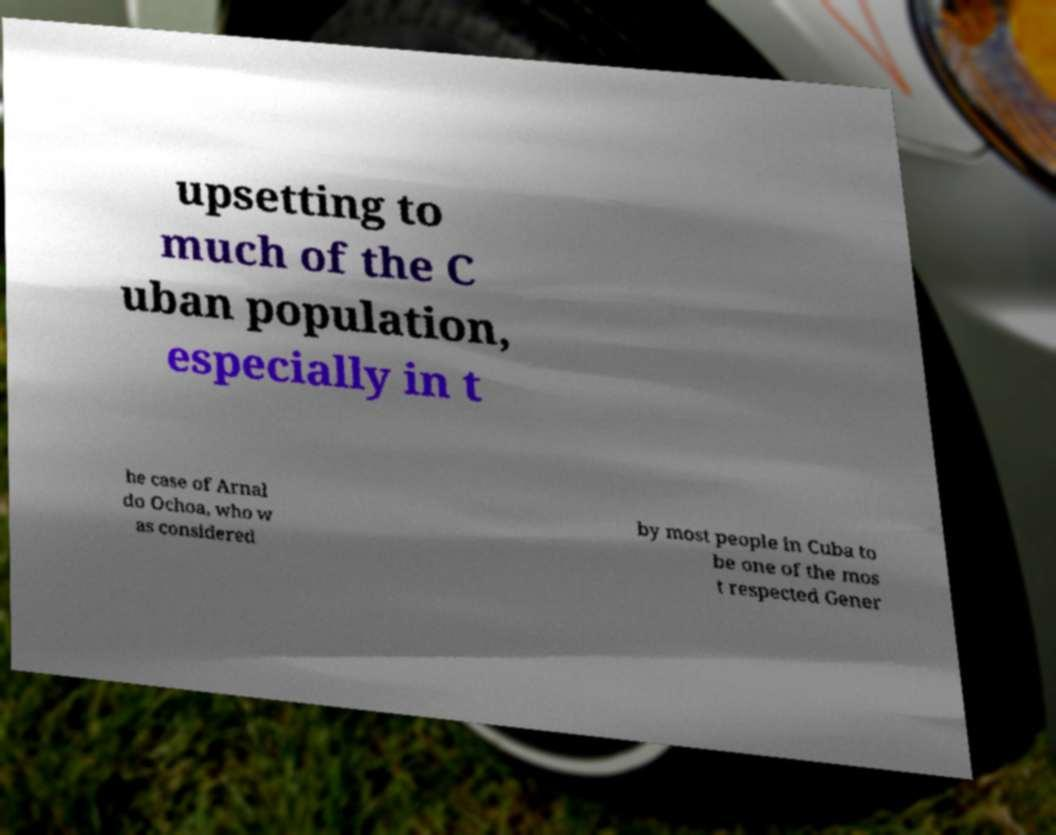Can you accurately transcribe the text from the provided image for me? upsetting to much of the C uban population, especially in t he case of Arnal do Ochoa, who w as considered by most people in Cuba to be one of the mos t respected Gener 